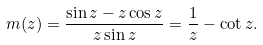<formula> <loc_0><loc_0><loc_500><loc_500>m ( z ) = \frac { \sin z - z \cos z } { z \sin z } = \frac { 1 } { z } - \cot z .</formula> 